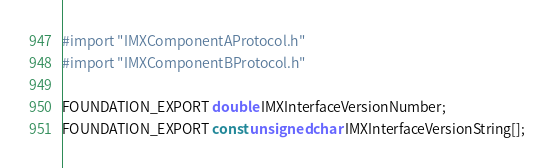Convert code to text. <code><loc_0><loc_0><loc_500><loc_500><_C_>
#import "IMXComponentAProtocol.h"
#import "IMXComponentBProtocol.h"

FOUNDATION_EXPORT double IMXInterfaceVersionNumber;
FOUNDATION_EXPORT const unsigned char IMXInterfaceVersionString[];

</code> 